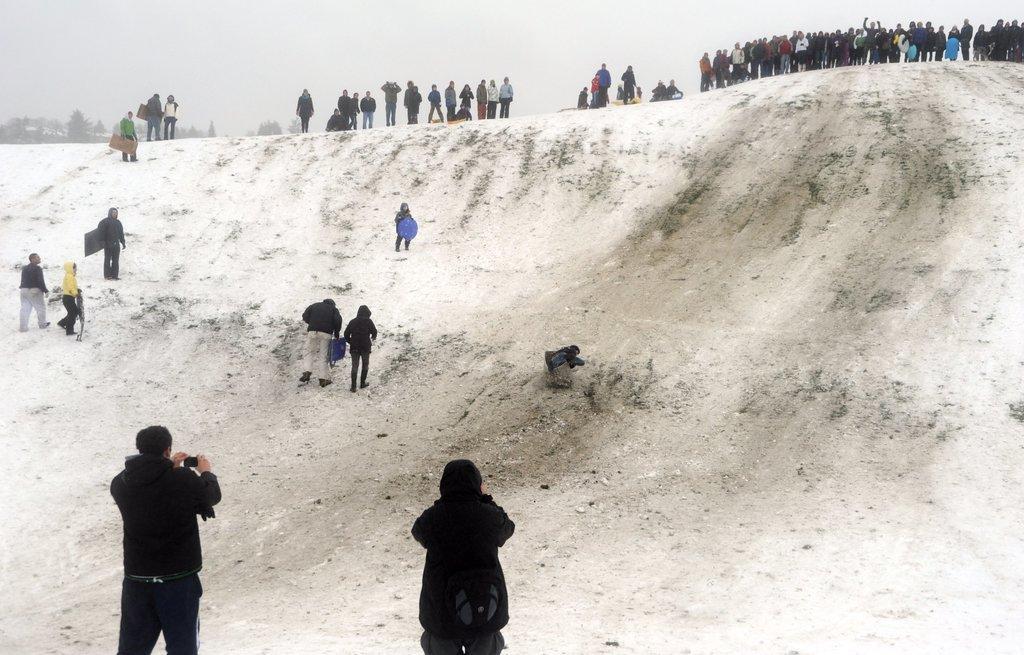Describe this image in one or two sentences. In this picture we can see some people are standing, a person in the front is holding a mobile phone, there are four persons walking in the middle, in the background there are some trees, we can see the sky at the top of the picture. 